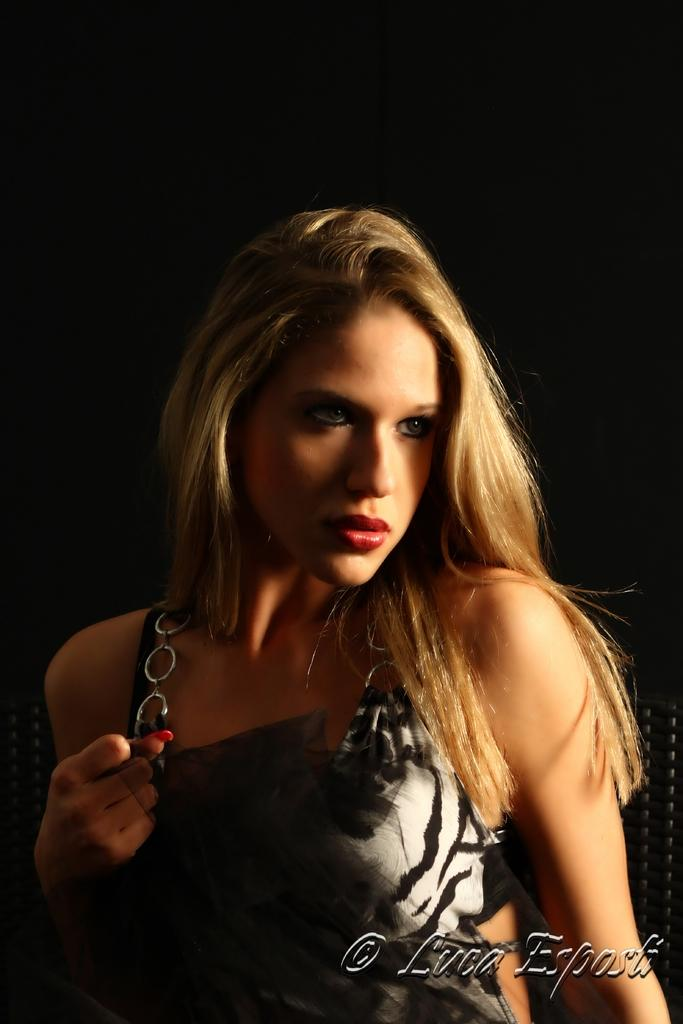Who or what is the main subject in the image? There is a person in the image. What is the person doing in the image? The person is sitting on a chair. Is there any text present in the image? Yes, there is some text at the bottom of the image. How many friends are visible in the image? There is no mention of friends in the image, and only one person is present. What type of stocking is the person wearing in the image? There is no information about the person's clothing, including stockings, in the image. 